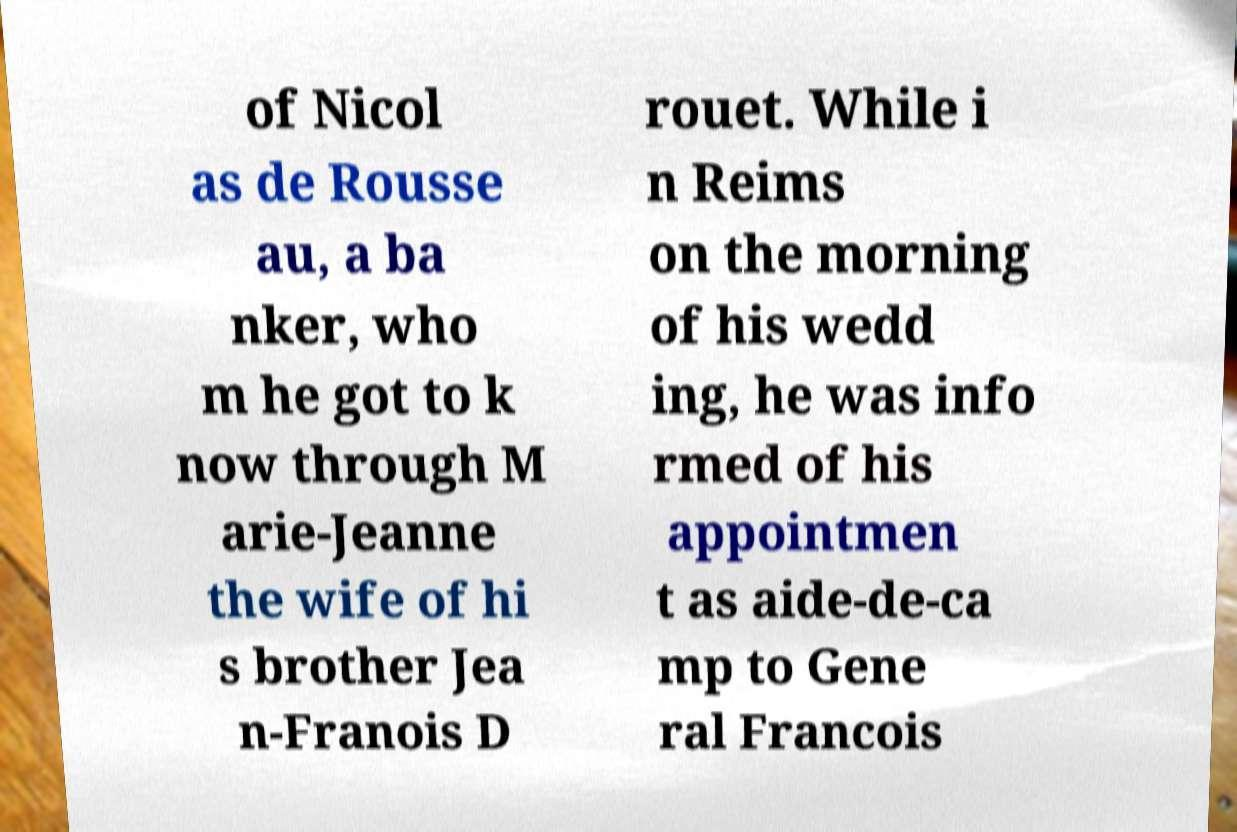Can you read and provide the text displayed in the image?This photo seems to have some interesting text. Can you extract and type it out for me? of Nicol as de Rousse au, a ba nker, who m he got to k now through M arie-Jeanne the wife of hi s brother Jea n-Franois D rouet. While i n Reims on the morning of his wedd ing, he was info rmed of his appointmen t as aide-de-ca mp to Gene ral Francois 